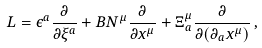<formula> <loc_0><loc_0><loc_500><loc_500>L = \epsilon ^ { a } \frac { \partial } { \partial \xi ^ { a } } + B N ^ { \mu } \frac { \partial } { \partial x ^ { \mu } } + \Xi ^ { \mu } _ { a } \frac { \partial } { \partial ( \partial _ { a } x ^ { \mu } ) } \, ,</formula> 